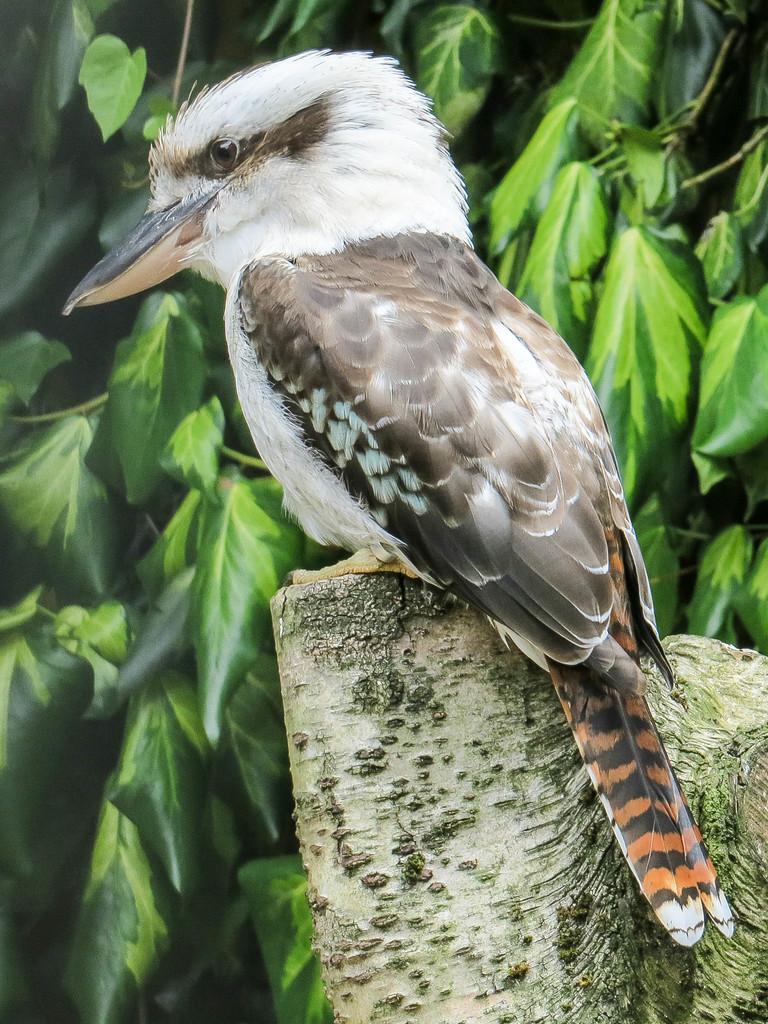What type of animal is in the image? There is a bird in the image. What colors can be seen on the bird? The bird is in white and brown colors. Where is the bird located in the image? The bird is on a branch of a tree. What can be seen in the background of the image? There are leaves in the background of the image. What type of stem can be seen in the bird's beak in the image? There is no stem present in the bird's beak in the image. 